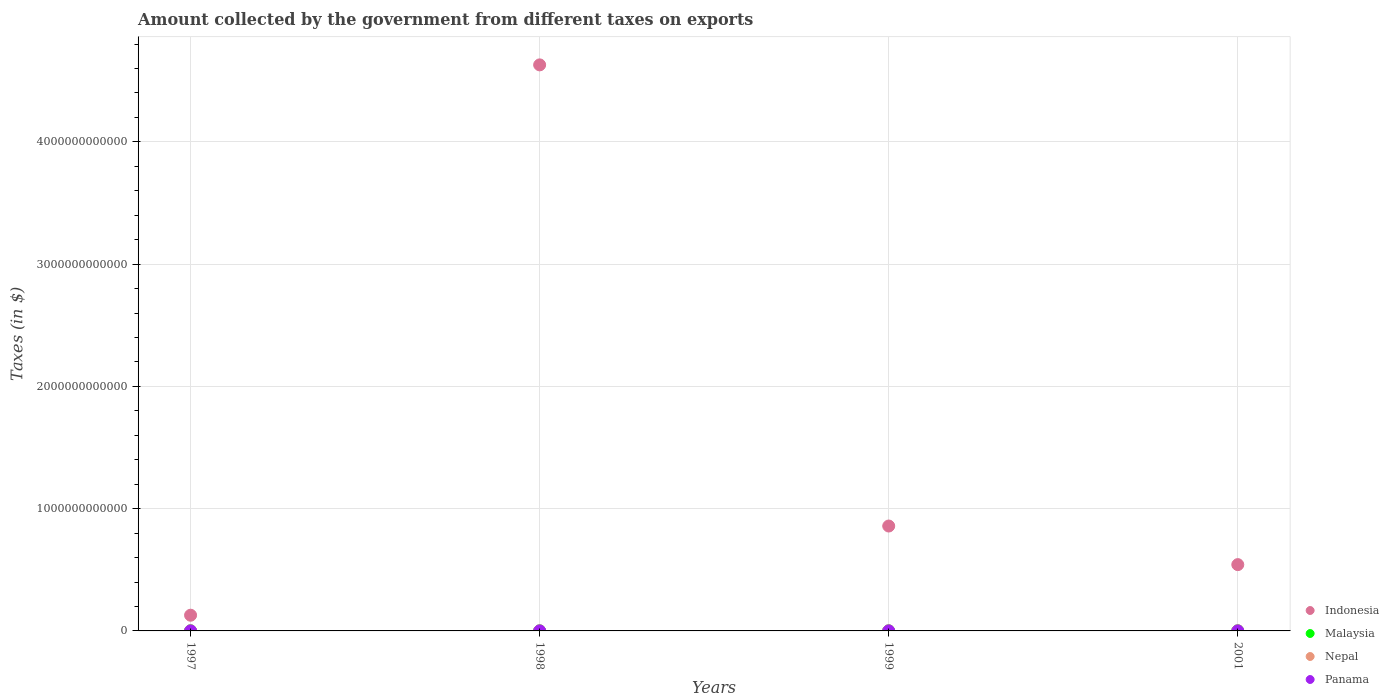Is the number of dotlines equal to the number of legend labels?
Your response must be concise. Yes. What is the amount collected by the government from taxes on exports in Malaysia in 1998?
Your response must be concise. 6.23e+08. Across all years, what is the maximum amount collected by the government from taxes on exports in Nepal?
Offer a terse response. 4.93e+08. In which year was the amount collected by the government from taxes on exports in Indonesia maximum?
Provide a short and direct response. 1998. In which year was the amount collected by the government from taxes on exports in Indonesia minimum?
Keep it short and to the point. 1997. What is the total amount collected by the government from taxes on exports in Malaysia in the graph?
Provide a short and direct response. 3.21e+09. What is the difference between the amount collected by the government from taxes on exports in Panama in 1998 and that in 1999?
Keep it short and to the point. 2.30e+06. What is the difference between the amount collected by the government from taxes on exports in Indonesia in 1998 and the amount collected by the government from taxes on exports in Panama in 1999?
Your answer should be very brief. 4.63e+12. What is the average amount collected by the government from taxes on exports in Indonesia per year?
Give a very brief answer. 1.54e+12. In the year 2001, what is the difference between the amount collected by the government from taxes on exports in Nepal and amount collected by the government from taxes on exports in Panama?
Your answer should be compact. 4.93e+08. In how many years, is the amount collected by the government from taxes on exports in Malaysia greater than 2600000000000 $?
Give a very brief answer. 0. What is the ratio of the amount collected by the government from taxes on exports in Indonesia in 1997 to that in 2001?
Your answer should be compact. 0.24. Is the amount collected by the government from taxes on exports in Nepal in 1999 less than that in 2001?
Make the answer very short. Yes. Is the difference between the amount collected by the government from taxes on exports in Nepal in 1998 and 1999 greater than the difference between the amount collected by the government from taxes on exports in Panama in 1998 and 1999?
Make the answer very short. No. What is the difference between the highest and the second highest amount collected by the government from taxes on exports in Malaysia?
Make the answer very short. 1.86e+08. What is the difference between the highest and the lowest amount collected by the government from taxes on exports in Nepal?
Make the answer very short. 3.25e+08. In how many years, is the amount collected by the government from taxes on exports in Nepal greater than the average amount collected by the government from taxes on exports in Nepal taken over all years?
Offer a very short reply. 2. Is the sum of the amount collected by the government from taxes on exports in Malaysia in 1997 and 1998 greater than the maximum amount collected by the government from taxes on exports in Panama across all years?
Offer a terse response. Yes. Is it the case that in every year, the sum of the amount collected by the government from taxes on exports in Indonesia and amount collected by the government from taxes on exports in Nepal  is greater than the amount collected by the government from taxes on exports in Malaysia?
Provide a short and direct response. Yes. Is the amount collected by the government from taxes on exports in Nepal strictly greater than the amount collected by the government from taxes on exports in Malaysia over the years?
Give a very brief answer. No. How many dotlines are there?
Make the answer very short. 4. What is the difference between two consecutive major ticks on the Y-axis?
Provide a succinct answer. 1.00e+12. Does the graph contain grids?
Make the answer very short. Yes. How are the legend labels stacked?
Your response must be concise. Vertical. What is the title of the graph?
Provide a succinct answer. Amount collected by the government from different taxes on exports. Does "Brunei Darussalam" appear as one of the legend labels in the graph?
Make the answer very short. No. What is the label or title of the Y-axis?
Provide a short and direct response. Taxes (in $). What is the Taxes (in $) of Indonesia in 1997?
Keep it short and to the point. 1.28e+11. What is the Taxes (in $) of Malaysia in 1997?
Make the answer very short. 1.05e+09. What is the Taxes (in $) of Nepal in 1997?
Give a very brief answer. 1.68e+08. What is the Taxes (in $) of Panama in 1997?
Keep it short and to the point. 6.20e+06. What is the Taxes (in $) of Indonesia in 1998?
Your answer should be very brief. 4.63e+12. What is the Taxes (in $) of Malaysia in 1998?
Your answer should be very brief. 6.23e+08. What is the Taxes (in $) of Nepal in 1998?
Your answer should be very brief. 2.17e+08. What is the Taxes (in $) of Panama in 1998?
Give a very brief answer. 2.90e+06. What is the Taxes (in $) in Indonesia in 1999?
Give a very brief answer. 8.58e+11. What is the Taxes (in $) in Malaysia in 1999?
Make the answer very short. 6.70e+08. What is the Taxes (in $) of Nepal in 1999?
Offer a terse response. 3.78e+08. What is the Taxes (in $) of Indonesia in 2001?
Offer a terse response. 5.42e+11. What is the Taxes (in $) in Malaysia in 2001?
Provide a succinct answer. 8.67e+08. What is the Taxes (in $) in Nepal in 2001?
Your response must be concise. 4.93e+08. What is the Taxes (in $) of Panama in 2001?
Your response must be concise. 4.00e+04. Across all years, what is the maximum Taxes (in $) of Indonesia?
Provide a short and direct response. 4.63e+12. Across all years, what is the maximum Taxes (in $) of Malaysia?
Offer a terse response. 1.05e+09. Across all years, what is the maximum Taxes (in $) of Nepal?
Provide a short and direct response. 4.93e+08. Across all years, what is the maximum Taxes (in $) in Panama?
Make the answer very short. 6.20e+06. Across all years, what is the minimum Taxes (in $) in Indonesia?
Provide a succinct answer. 1.28e+11. Across all years, what is the minimum Taxes (in $) in Malaysia?
Offer a very short reply. 6.23e+08. Across all years, what is the minimum Taxes (in $) in Nepal?
Offer a terse response. 1.68e+08. Across all years, what is the minimum Taxes (in $) of Panama?
Provide a succinct answer. 4.00e+04. What is the total Taxes (in $) in Indonesia in the graph?
Keep it short and to the point. 6.16e+12. What is the total Taxes (in $) in Malaysia in the graph?
Keep it short and to the point. 3.21e+09. What is the total Taxes (in $) of Nepal in the graph?
Offer a very short reply. 1.26e+09. What is the total Taxes (in $) in Panama in the graph?
Ensure brevity in your answer.  9.74e+06. What is the difference between the Taxes (in $) in Indonesia in 1997 and that in 1998?
Your answer should be compact. -4.50e+12. What is the difference between the Taxes (in $) of Malaysia in 1997 and that in 1998?
Provide a succinct answer. 4.30e+08. What is the difference between the Taxes (in $) of Nepal in 1997 and that in 1998?
Give a very brief answer. -4.90e+07. What is the difference between the Taxes (in $) in Panama in 1997 and that in 1998?
Keep it short and to the point. 3.30e+06. What is the difference between the Taxes (in $) in Indonesia in 1997 and that in 1999?
Provide a short and direct response. -7.30e+11. What is the difference between the Taxes (in $) in Malaysia in 1997 and that in 1999?
Give a very brief answer. 3.83e+08. What is the difference between the Taxes (in $) of Nepal in 1997 and that in 1999?
Provide a succinct answer. -2.10e+08. What is the difference between the Taxes (in $) of Panama in 1997 and that in 1999?
Your answer should be very brief. 5.60e+06. What is the difference between the Taxes (in $) in Indonesia in 1997 and that in 2001?
Ensure brevity in your answer.  -4.14e+11. What is the difference between the Taxes (in $) in Malaysia in 1997 and that in 2001?
Keep it short and to the point. 1.86e+08. What is the difference between the Taxes (in $) of Nepal in 1997 and that in 2001?
Offer a terse response. -3.25e+08. What is the difference between the Taxes (in $) in Panama in 1997 and that in 2001?
Give a very brief answer. 6.16e+06. What is the difference between the Taxes (in $) of Indonesia in 1998 and that in 1999?
Make the answer very short. 3.77e+12. What is the difference between the Taxes (in $) in Malaysia in 1998 and that in 1999?
Your answer should be compact. -4.70e+07. What is the difference between the Taxes (in $) in Nepal in 1998 and that in 1999?
Your answer should be very brief. -1.61e+08. What is the difference between the Taxes (in $) of Panama in 1998 and that in 1999?
Ensure brevity in your answer.  2.30e+06. What is the difference between the Taxes (in $) of Indonesia in 1998 and that in 2001?
Give a very brief answer. 4.09e+12. What is the difference between the Taxes (in $) in Malaysia in 1998 and that in 2001?
Offer a very short reply. -2.44e+08. What is the difference between the Taxes (in $) of Nepal in 1998 and that in 2001?
Offer a terse response. -2.76e+08. What is the difference between the Taxes (in $) of Panama in 1998 and that in 2001?
Give a very brief answer. 2.86e+06. What is the difference between the Taxes (in $) of Indonesia in 1999 and that in 2001?
Ensure brevity in your answer.  3.16e+11. What is the difference between the Taxes (in $) in Malaysia in 1999 and that in 2001?
Provide a short and direct response. -1.97e+08. What is the difference between the Taxes (in $) in Nepal in 1999 and that in 2001?
Offer a very short reply. -1.15e+08. What is the difference between the Taxes (in $) of Panama in 1999 and that in 2001?
Ensure brevity in your answer.  5.60e+05. What is the difference between the Taxes (in $) in Indonesia in 1997 and the Taxes (in $) in Malaysia in 1998?
Provide a short and direct response. 1.28e+11. What is the difference between the Taxes (in $) of Indonesia in 1997 and the Taxes (in $) of Nepal in 1998?
Give a very brief answer. 1.28e+11. What is the difference between the Taxes (in $) in Indonesia in 1997 and the Taxes (in $) in Panama in 1998?
Provide a succinct answer. 1.28e+11. What is the difference between the Taxes (in $) of Malaysia in 1997 and the Taxes (in $) of Nepal in 1998?
Provide a succinct answer. 8.36e+08. What is the difference between the Taxes (in $) in Malaysia in 1997 and the Taxes (in $) in Panama in 1998?
Offer a terse response. 1.05e+09. What is the difference between the Taxes (in $) of Nepal in 1997 and the Taxes (in $) of Panama in 1998?
Keep it short and to the point. 1.65e+08. What is the difference between the Taxes (in $) in Indonesia in 1997 and the Taxes (in $) in Malaysia in 1999?
Offer a very short reply. 1.28e+11. What is the difference between the Taxes (in $) of Indonesia in 1997 and the Taxes (in $) of Nepal in 1999?
Provide a succinct answer. 1.28e+11. What is the difference between the Taxes (in $) in Indonesia in 1997 and the Taxes (in $) in Panama in 1999?
Keep it short and to the point. 1.28e+11. What is the difference between the Taxes (in $) in Malaysia in 1997 and the Taxes (in $) in Nepal in 1999?
Provide a short and direct response. 6.75e+08. What is the difference between the Taxes (in $) of Malaysia in 1997 and the Taxes (in $) of Panama in 1999?
Provide a short and direct response. 1.05e+09. What is the difference between the Taxes (in $) in Nepal in 1997 and the Taxes (in $) in Panama in 1999?
Give a very brief answer. 1.67e+08. What is the difference between the Taxes (in $) of Indonesia in 1997 and the Taxes (in $) of Malaysia in 2001?
Provide a short and direct response. 1.28e+11. What is the difference between the Taxes (in $) in Indonesia in 1997 and the Taxes (in $) in Nepal in 2001?
Your answer should be very brief. 1.28e+11. What is the difference between the Taxes (in $) of Indonesia in 1997 and the Taxes (in $) of Panama in 2001?
Provide a succinct answer. 1.28e+11. What is the difference between the Taxes (in $) of Malaysia in 1997 and the Taxes (in $) of Nepal in 2001?
Ensure brevity in your answer.  5.60e+08. What is the difference between the Taxes (in $) of Malaysia in 1997 and the Taxes (in $) of Panama in 2001?
Provide a succinct answer. 1.05e+09. What is the difference between the Taxes (in $) of Nepal in 1997 and the Taxes (in $) of Panama in 2001?
Keep it short and to the point. 1.68e+08. What is the difference between the Taxes (in $) in Indonesia in 1998 and the Taxes (in $) in Malaysia in 1999?
Offer a terse response. 4.63e+12. What is the difference between the Taxes (in $) of Indonesia in 1998 and the Taxes (in $) of Nepal in 1999?
Your response must be concise. 4.63e+12. What is the difference between the Taxes (in $) in Indonesia in 1998 and the Taxes (in $) in Panama in 1999?
Ensure brevity in your answer.  4.63e+12. What is the difference between the Taxes (in $) of Malaysia in 1998 and the Taxes (in $) of Nepal in 1999?
Your answer should be compact. 2.45e+08. What is the difference between the Taxes (in $) in Malaysia in 1998 and the Taxes (in $) in Panama in 1999?
Make the answer very short. 6.22e+08. What is the difference between the Taxes (in $) of Nepal in 1998 and the Taxes (in $) of Panama in 1999?
Provide a short and direct response. 2.16e+08. What is the difference between the Taxes (in $) of Indonesia in 1998 and the Taxes (in $) of Malaysia in 2001?
Offer a very short reply. 4.63e+12. What is the difference between the Taxes (in $) in Indonesia in 1998 and the Taxes (in $) in Nepal in 2001?
Make the answer very short. 4.63e+12. What is the difference between the Taxes (in $) in Indonesia in 1998 and the Taxes (in $) in Panama in 2001?
Offer a very short reply. 4.63e+12. What is the difference between the Taxes (in $) in Malaysia in 1998 and the Taxes (in $) in Nepal in 2001?
Your answer should be very brief. 1.30e+08. What is the difference between the Taxes (in $) in Malaysia in 1998 and the Taxes (in $) in Panama in 2001?
Give a very brief answer. 6.23e+08. What is the difference between the Taxes (in $) of Nepal in 1998 and the Taxes (in $) of Panama in 2001?
Make the answer very short. 2.17e+08. What is the difference between the Taxes (in $) of Indonesia in 1999 and the Taxes (in $) of Malaysia in 2001?
Offer a very short reply. 8.57e+11. What is the difference between the Taxes (in $) in Indonesia in 1999 and the Taxes (in $) in Nepal in 2001?
Offer a very short reply. 8.58e+11. What is the difference between the Taxes (in $) of Indonesia in 1999 and the Taxes (in $) of Panama in 2001?
Keep it short and to the point. 8.58e+11. What is the difference between the Taxes (in $) in Malaysia in 1999 and the Taxes (in $) in Nepal in 2001?
Make the answer very short. 1.77e+08. What is the difference between the Taxes (in $) of Malaysia in 1999 and the Taxes (in $) of Panama in 2001?
Provide a short and direct response. 6.70e+08. What is the difference between the Taxes (in $) of Nepal in 1999 and the Taxes (in $) of Panama in 2001?
Give a very brief answer. 3.78e+08. What is the average Taxes (in $) in Indonesia per year?
Provide a short and direct response. 1.54e+12. What is the average Taxes (in $) of Malaysia per year?
Provide a succinct answer. 8.03e+08. What is the average Taxes (in $) in Nepal per year?
Your answer should be very brief. 3.14e+08. What is the average Taxes (in $) in Panama per year?
Offer a terse response. 2.44e+06. In the year 1997, what is the difference between the Taxes (in $) of Indonesia and Taxes (in $) of Malaysia?
Make the answer very short. 1.27e+11. In the year 1997, what is the difference between the Taxes (in $) of Indonesia and Taxes (in $) of Nepal?
Ensure brevity in your answer.  1.28e+11. In the year 1997, what is the difference between the Taxes (in $) of Indonesia and Taxes (in $) of Panama?
Give a very brief answer. 1.28e+11. In the year 1997, what is the difference between the Taxes (in $) in Malaysia and Taxes (in $) in Nepal?
Offer a very short reply. 8.85e+08. In the year 1997, what is the difference between the Taxes (in $) in Malaysia and Taxes (in $) in Panama?
Your answer should be compact. 1.05e+09. In the year 1997, what is the difference between the Taxes (in $) of Nepal and Taxes (in $) of Panama?
Offer a terse response. 1.62e+08. In the year 1998, what is the difference between the Taxes (in $) of Indonesia and Taxes (in $) of Malaysia?
Provide a succinct answer. 4.63e+12. In the year 1998, what is the difference between the Taxes (in $) of Indonesia and Taxes (in $) of Nepal?
Keep it short and to the point. 4.63e+12. In the year 1998, what is the difference between the Taxes (in $) in Indonesia and Taxes (in $) in Panama?
Your answer should be compact. 4.63e+12. In the year 1998, what is the difference between the Taxes (in $) of Malaysia and Taxes (in $) of Nepal?
Offer a terse response. 4.06e+08. In the year 1998, what is the difference between the Taxes (in $) in Malaysia and Taxes (in $) in Panama?
Ensure brevity in your answer.  6.20e+08. In the year 1998, what is the difference between the Taxes (in $) in Nepal and Taxes (in $) in Panama?
Your answer should be compact. 2.14e+08. In the year 1999, what is the difference between the Taxes (in $) in Indonesia and Taxes (in $) in Malaysia?
Provide a succinct answer. 8.57e+11. In the year 1999, what is the difference between the Taxes (in $) of Indonesia and Taxes (in $) of Nepal?
Make the answer very short. 8.58e+11. In the year 1999, what is the difference between the Taxes (in $) of Indonesia and Taxes (in $) of Panama?
Offer a very short reply. 8.58e+11. In the year 1999, what is the difference between the Taxes (in $) of Malaysia and Taxes (in $) of Nepal?
Provide a succinct answer. 2.92e+08. In the year 1999, what is the difference between the Taxes (in $) in Malaysia and Taxes (in $) in Panama?
Provide a succinct answer. 6.69e+08. In the year 1999, what is the difference between the Taxes (in $) in Nepal and Taxes (in $) in Panama?
Offer a terse response. 3.77e+08. In the year 2001, what is the difference between the Taxes (in $) in Indonesia and Taxes (in $) in Malaysia?
Ensure brevity in your answer.  5.41e+11. In the year 2001, what is the difference between the Taxes (in $) in Indonesia and Taxes (in $) in Nepal?
Offer a terse response. 5.42e+11. In the year 2001, what is the difference between the Taxes (in $) in Indonesia and Taxes (in $) in Panama?
Your response must be concise. 5.42e+11. In the year 2001, what is the difference between the Taxes (in $) of Malaysia and Taxes (in $) of Nepal?
Offer a very short reply. 3.74e+08. In the year 2001, what is the difference between the Taxes (in $) in Malaysia and Taxes (in $) in Panama?
Your response must be concise. 8.67e+08. In the year 2001, what is the difference between the Taxes (in $) in Nepal and Taxes (in $) in Panama?
Your answer should be very brief. 4.93e+08. What is the ratio of the Taxes (in $) of Indonesia in 1997 to that in 1998?
Your answer should be compact. 0.03. What is the ratio of the Taxes (in $) of Malaysia in 1997 to that in 1998?
Give a very brief answer. 1.69. What is the ratio of the Taxes (in $) in Nepal in 1997 to that in 1998?
Offer a terse response. 0.77. What is the ratio of the Taxes (in $) of Panama in 1997 to that in 1998?
Offer a terse response. 2.14. What is the ratio of the Taxes (in $) of Indonesia in 1997 to that in 1999?
Provide a succinct answer. 0.15. What is the ratio of the Taxes (in $) of Malaysia in 1997 to that in 1999?
Provide a succinct answer. 1.57. What is the ratio of the Taxes (in $) of Nepal in 1997 to that in 1999?
Make the answer very short. 0.44. What is the ratio of the Taxes (in $) in Panama in 1997 to that in 1999?
Offer a terse response. 10.33. What is the ratio of the Taxes (in $) of Indonesia in 1997 to that in 2001?
Ensure brevity in your answer.  0.24. What is the ratio of the Taxes (in $) of Malaysia in 1997 to that in 2001?
Your response must be concise. 1.21. What is the ratio of the Taxes (in $) of Nepal in 1997 to that in 2001?
Provide a succinct answer. 0.34. What is the ratio of the Taxes (in $) in Panama in 1997 to that in 2001?
Make the answer very short. 155. What is the ratio of the Taxes (in $) of Indonesia in 1998 to that in 1999?
Your answer should be very brief. 5.4. What is the ratio of the Taxes (in $) of Malaysia in 1998 to that in 1999?
Ensure brevity in your answer.  0.93. What is the ratio of the Taxes (in $) of Nepal in 1998 to that in 1999?
Your response must be concise. 0.57. What is the ratio of the Taxes (in $) in Panama in 1998 to that in 1999?
Provide a succinct answer. 4.83. What is the ratio of the Taxes (in $) of Indonesia in 1998 to that in 2001?
Offer a terse response. 8.54. What is the ratio of the Taxes (in $) in Malaysia in 1998 to that in 2001?
Ensure brevity in your answer.  0.72. What is the ratio of the Taxes (in $) in Nepal in 1998 to that in 2001?
Your answer should be compact. 0.44. What is the ratio of the Taxes (in $) in Panama in 1998 to that in 2001?
Your answer should be compact. 72.5. What is the ratio of the Taxes (in $) of Indonesia in 1999 to that in 2001?
Offer a very short reply. 1.58. What is the ratio of the Taxes (in $) in Malaysia in 1999 to that in 2001?
Give a very brief answer. 0.77. What is the ratio of the Taxes (in $) in Nepal in 1999 to that in 2001?
Keep it short and to the point. 0.77. What is the ratio of the Taxes (in $) of Panama in 1999 to that in 2001?
Offer a terse response. 15. What is the difference between the highest and the second highest Taxes (in $) in Indonesia?
Your answer should be compact. 3.77e+12. What is the difference between the highest and the second highest Taxes (in $) in Malaysia?
Offer a terse response. 1.86e+08. What is the difference between the highest and the second highest Taxes (in $) in Nepal?
Ensure brevity in your answer.  1.15e+08. What is the difference between the highest and the second highest Taxes (in $) in Panama?
Give a very brief answer. 3.30e+06. What is the difference between the highest and the lowest Taxes (in $) of Indonesia?
Provide a short and direct response. 4.50e+12. What is the difference between the highest and the lowest Taxes (in $) of Malaysia?
Your answer should be compact. 4.30e+08. What is the difference between the highest and the lowest Taxes (in $) of Nepal?
Your answer should be very brief. 3.25e+08. What is the difference between the highest and the lowest Taxes (in $) of Panama?
Provide a short and direct response. 6.16e+06. 